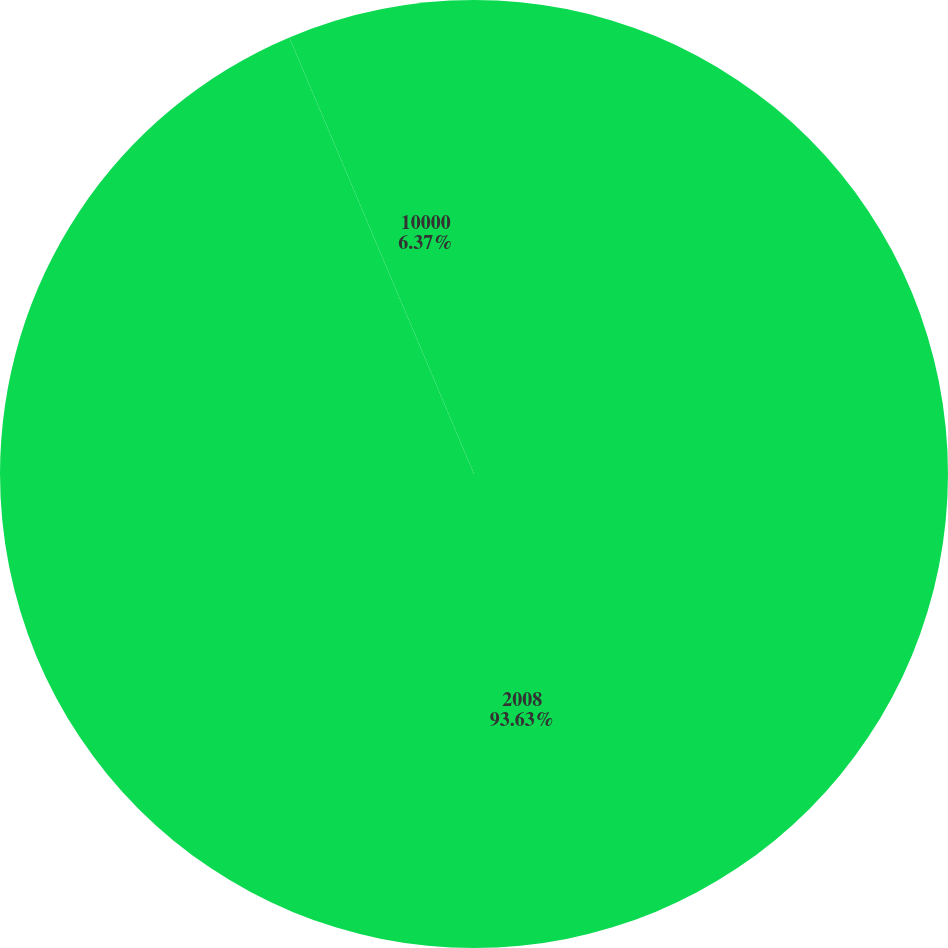<chart> <loc_0><loc_0><loc_500><loc_500><pie_chart><fcel>2008<fcel>10000<nl><fcel>93.63%<fcel>6.37%<nl></chart> 